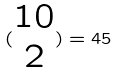<formula> <loc_0><loc_0><loc_500><loc_500>( \begin{matrix} 1 0 \\ 2 \end{matrix} ) = 4 5</formula> 